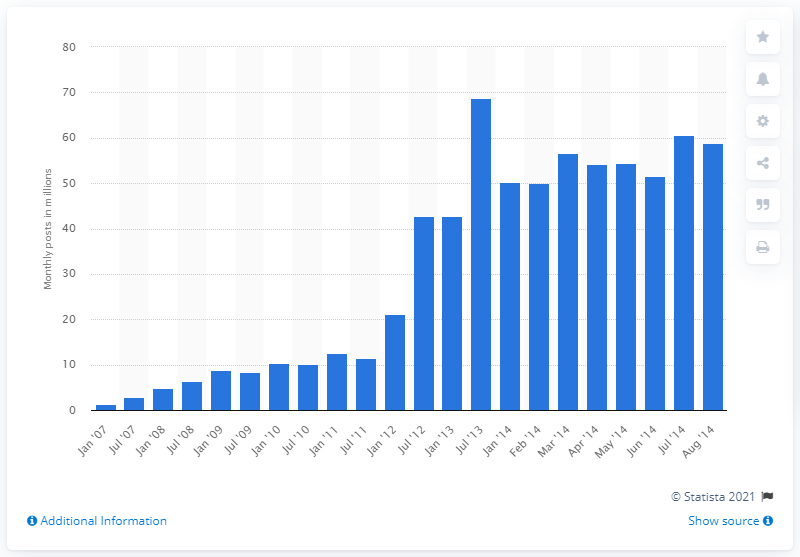Indicate a few pertinent items in this graphic. Between January 2007 and August 2014, WordPress users posted an average of 58.79 monthly comments. 